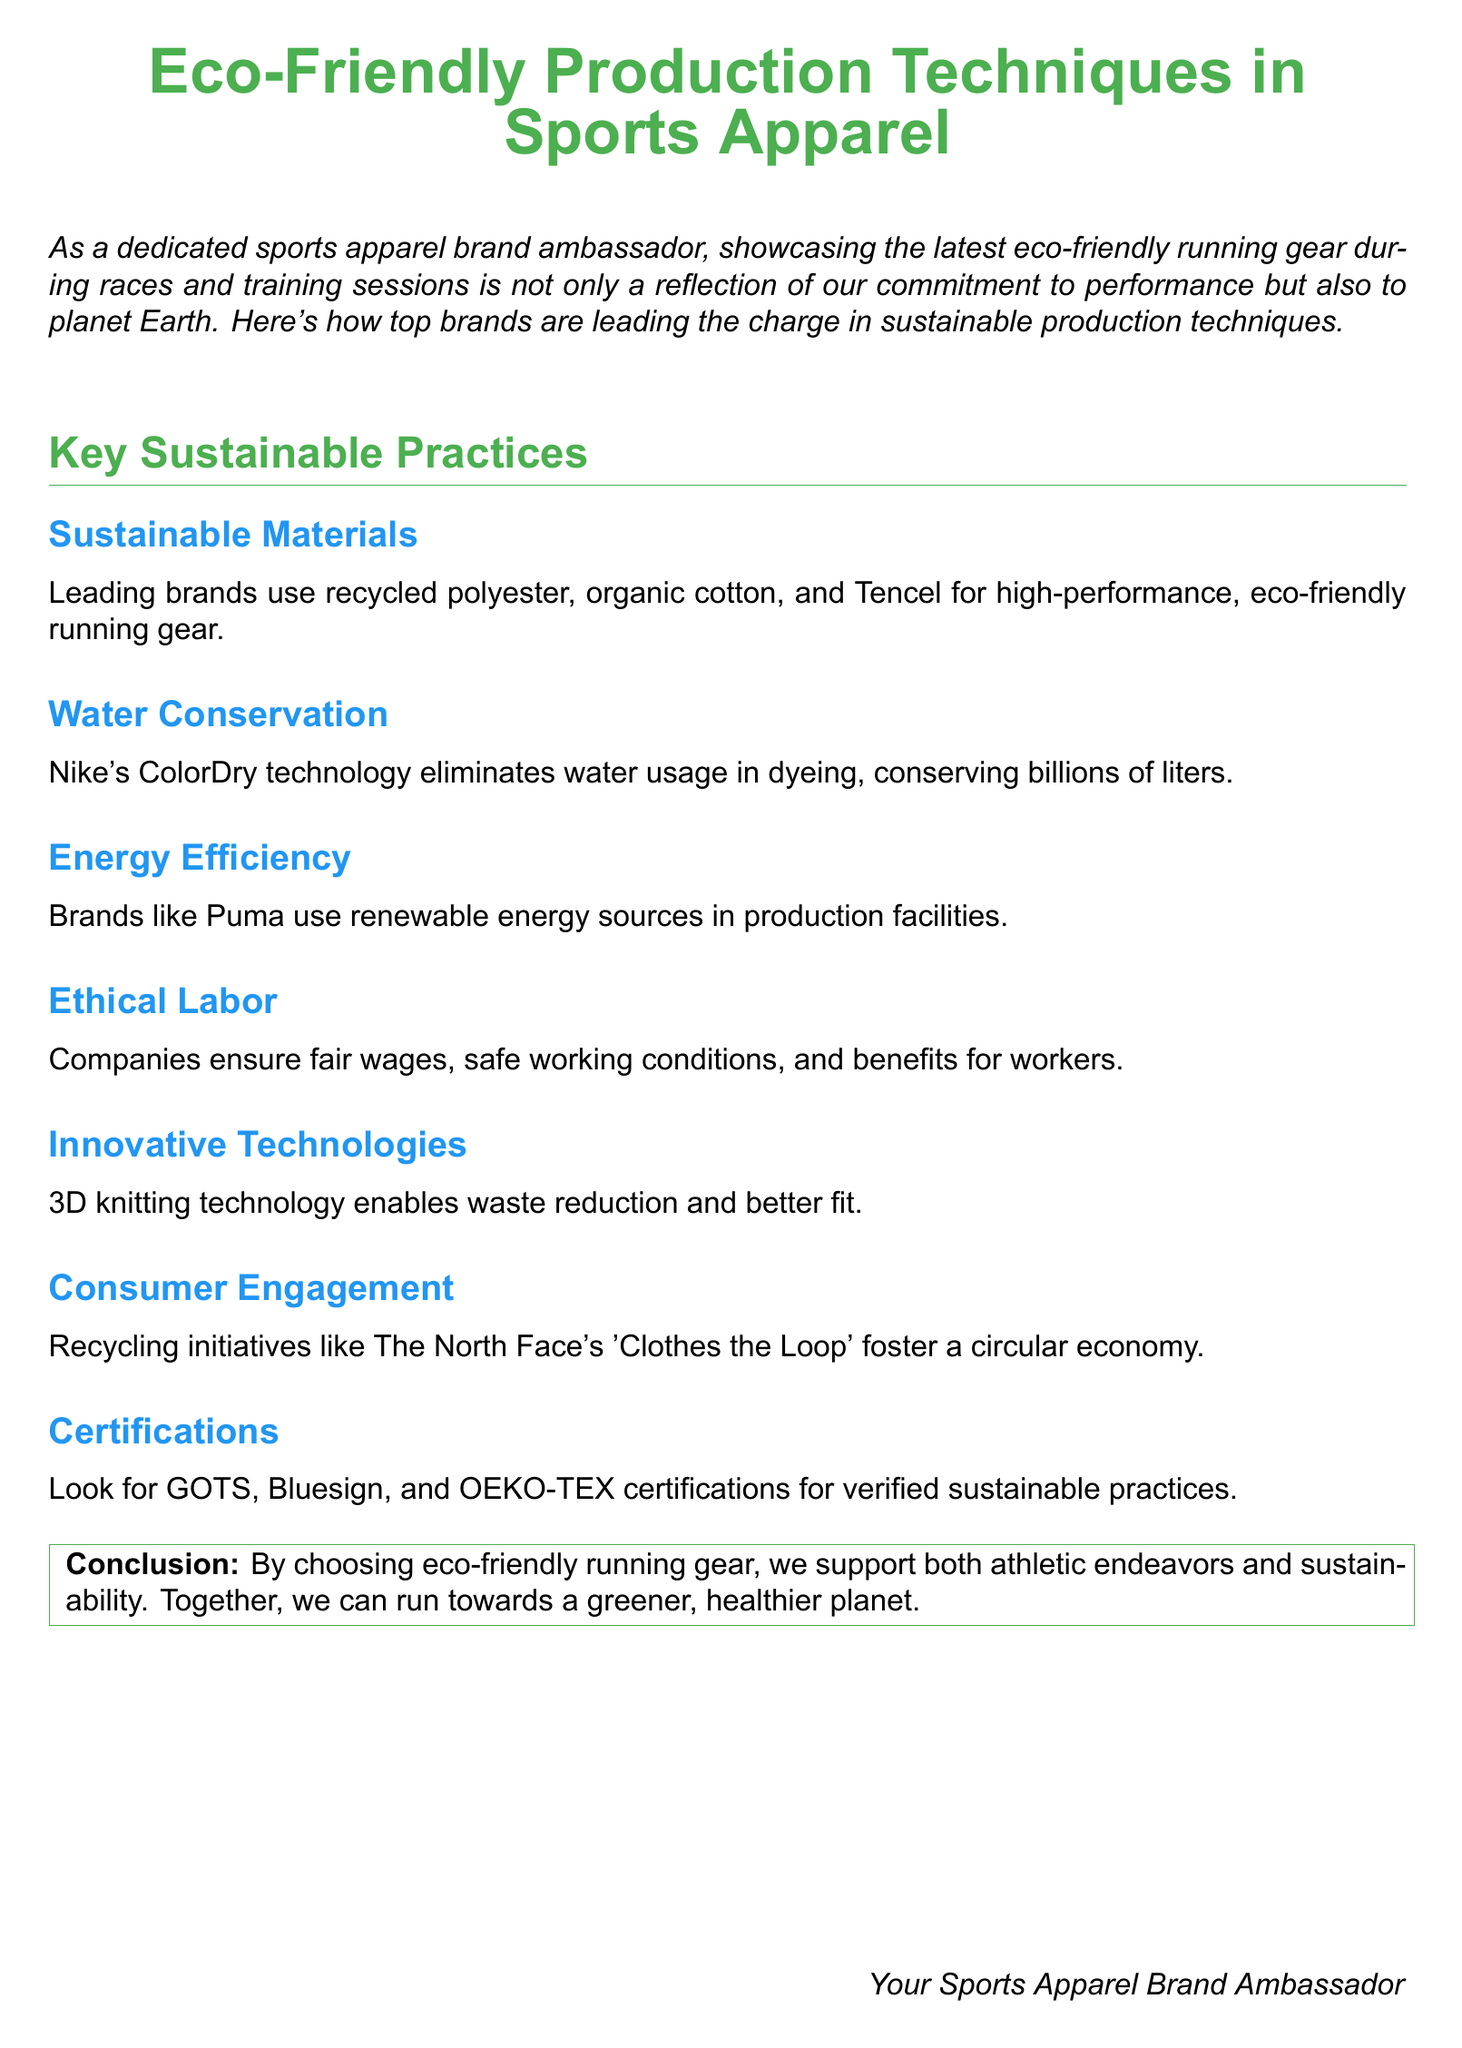what materials are mentioned for eco-friendly running gear? The document lists recycled polyester, organic cotton, and Tencel as sustainable materials used by leading brands.
Answer: recycled polyester, organic cotton, Tencel how does Nike conserve water in production? Nike's ColorDry technology is specified for eliminating water usage in dyeing processes, which conserves billions of liters.
Answer: ColorDry technology which company uses renewable energy in their production? The document states that Puma employs renewable energy sources in its production facilities.
Answer: Puma what certifications should consumers look for regarding sustainability? The document mentions GOTS, Bluesign, and OEKO-TEX as certifications indicating verified sustainable practices.
Answer: GOTS, Bluesign, OEKO-TEX what is the purpose of The North Face's 'Clothes the Loop'? It is described in the document as an initiative that fosters a circular economy by engaging consumers in recycling.
Answer: foster a circular economy how do eco-friendly practices benefit athletes? The document concludes that choosing eco-friendly gear supports both athletic endeavors and sustainability.
Answer: supports athletic endeavors and sustainability what is a key technique for waste reduction in sports apparel? The document highlights 3D knitting technology as an innovative technique that enables waste reduction.
Answer: 3D knitting technology which section covers ethical labor practices? The section titled "Ethical Labor" discusses fair wages, safe working conditions, and benefits for workers.
Answer: Ethical Labor 